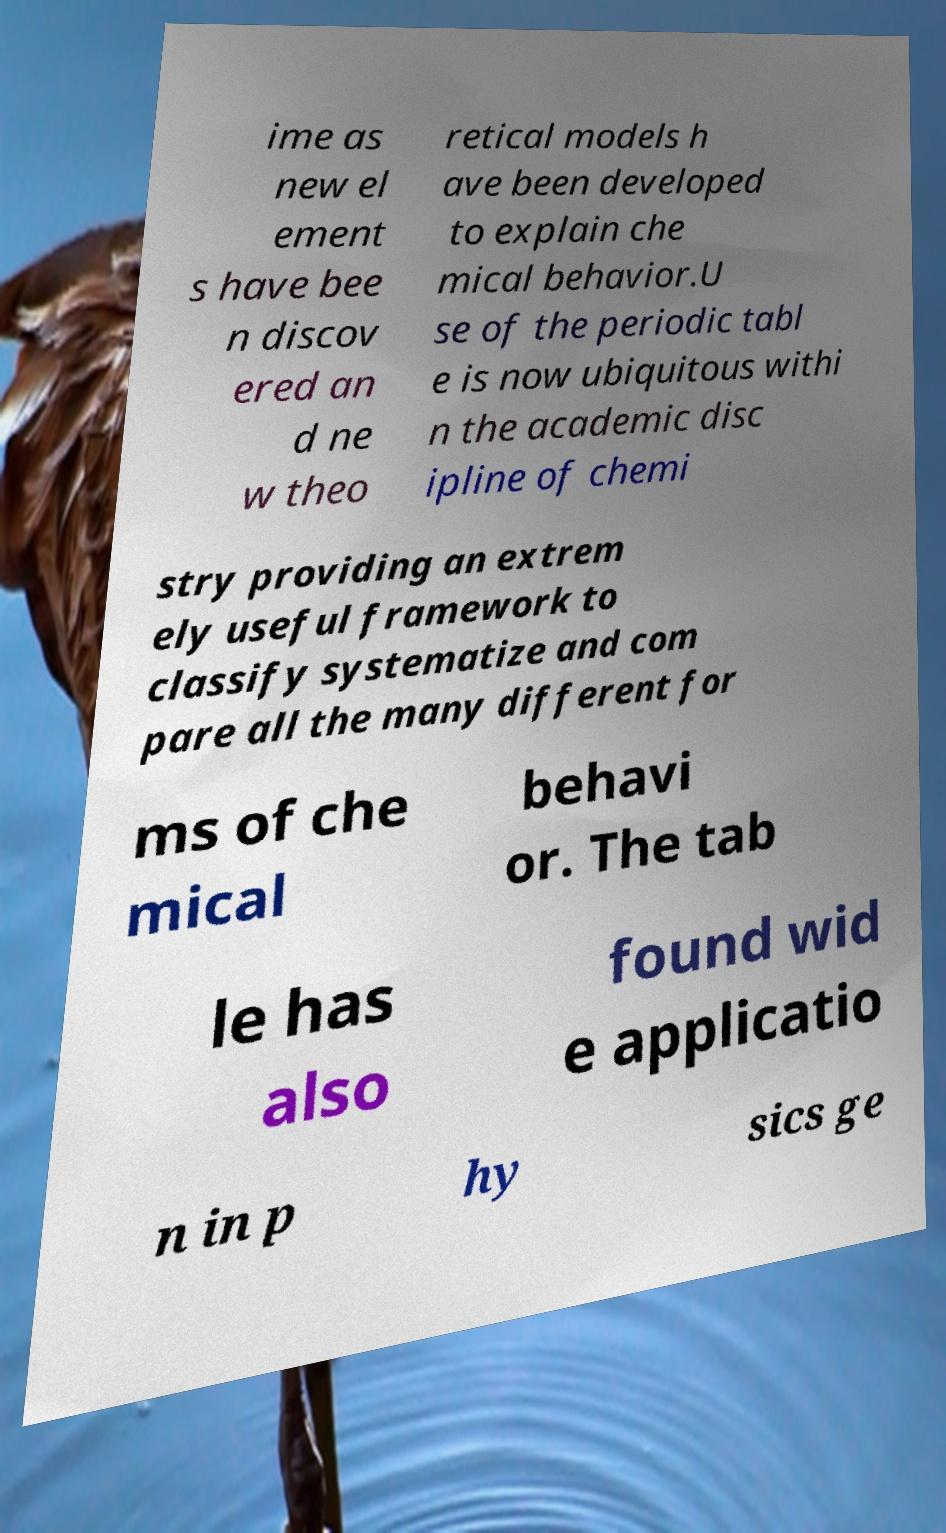Please identify and transcribe the text found in this image. ime as new el ement s have bee n discov ered an d ne w theo retical models h ave been developed to explain che mical behavior.U se of the periodic tabl e is now ubiquitous withi n the academic disc ipline of chemi stry providing an extrem ely useful framework to classify systematize and com pare all the many different for ms of che mical behavi or. The tab le has also found wid e applicatio n in p hy sics ge 